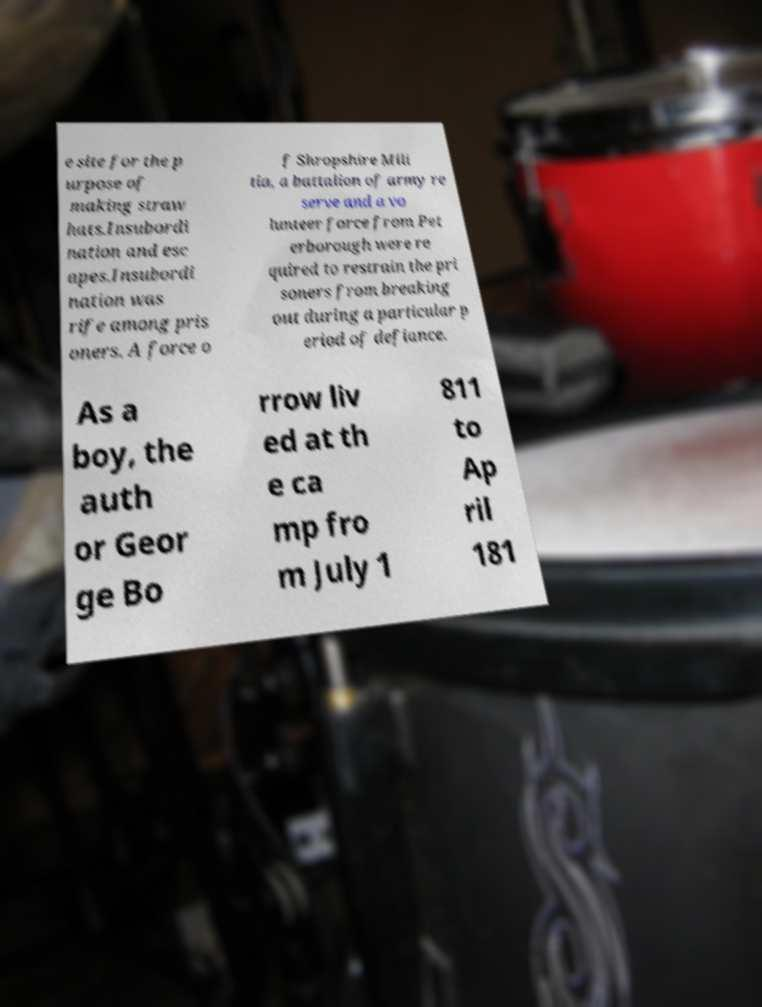Could you extract and type out the text from this image? e site for the p urpose of making straw hats.Insubordi nation and esc apes.Insubordi nation was rife among pris oners. A force o f Shropshire Mili tia, a battalion of army re serve and a vo lunteer force from Pet erborough were re quired to restrain the pri soners from breaking out during a particular p eriod of defiance. As a boy, the auth or Geor ge Bo rrow liv ed at th e ca mp fro m July 1 811 to Ap ril 181 